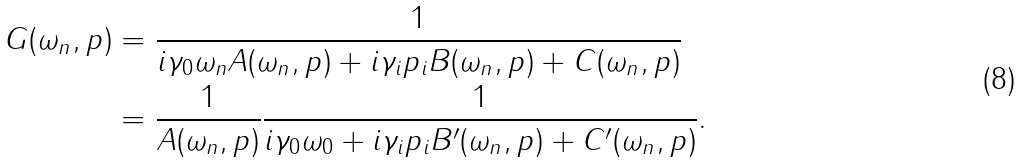<formula> <loc_0><loc_0><loc_500><loc_500>G ( \omega _ { n } , p ) & = \frac { 1 } { i \gamma _ { 0 } \omega _ { n } A ( \omega _ { n } , p ) + i \gamma _ { i } p _ { i } B ( \omega _ { n } , p ) + C ( \omega _ { n } , p ) } \\ & = \frac { 1 } { A ( \omega _ { n } , p ) } \frac { 1 } { i \gamma _ { 0 } \omega _ { 0 } + i \gamma _ { i } p _ { i } B ^ { \prime } ( \omega _ { n } , p ) + C ^ { \prime } ( \omega _ { n } , p ) } .</formula> 